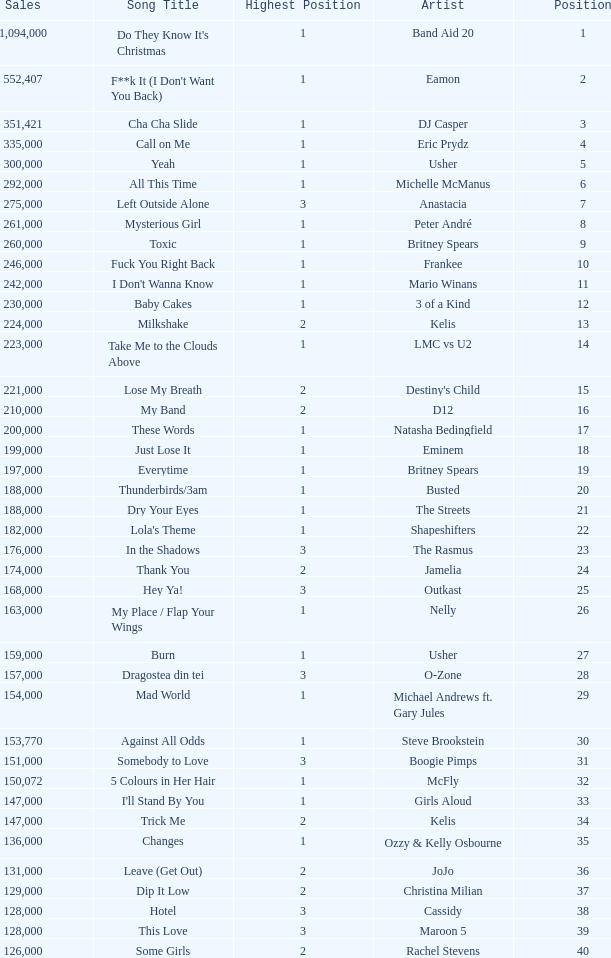What were the sales for Dj Casper when he was in a position lower than 13? 351421.0. 